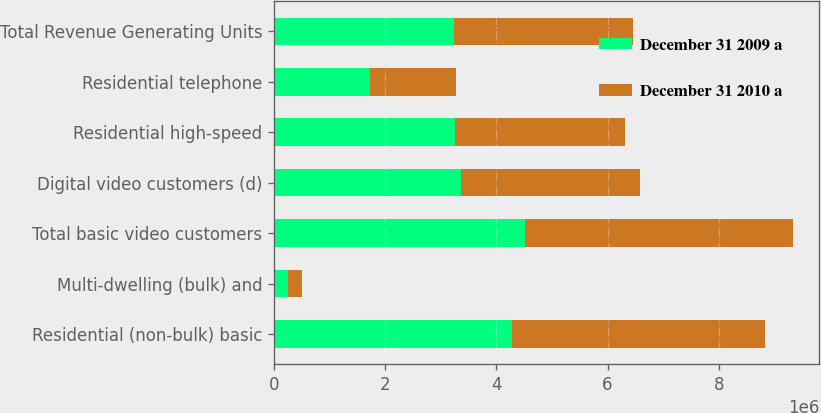Convert chart to OTSL. <chart><loc_0><loc_0><loc_500><loc_500><stacked_bar_chart><ecel><fcel>Residential (non-bulk) basic<fcel>Multi-dwelling (bulk) and<fcel>Total basic video customers<fcel>Digital video customers (d)<fcel>Residential high-speed<fcel>Residential telephone<fcel>Total Revenue Generating Units<nl><fcel>December 31 2009 a<fcel>4.2784e+06<fcel>242000<fcel>4.5204e+06<fcel>3.3632e+06<fcel>3.2461e+06<fcel>1.717e+06<fcel>3.2321e+06<nl><fcel>December 31 2010 a<fcel>4.5629e+06<fcel>261100<fcel>4.824e+06<fcel>3.2181e+06<fcel>3.0623e+06<fcel>1.556e+06<fcel>3.2321e+06<nl></chart> 